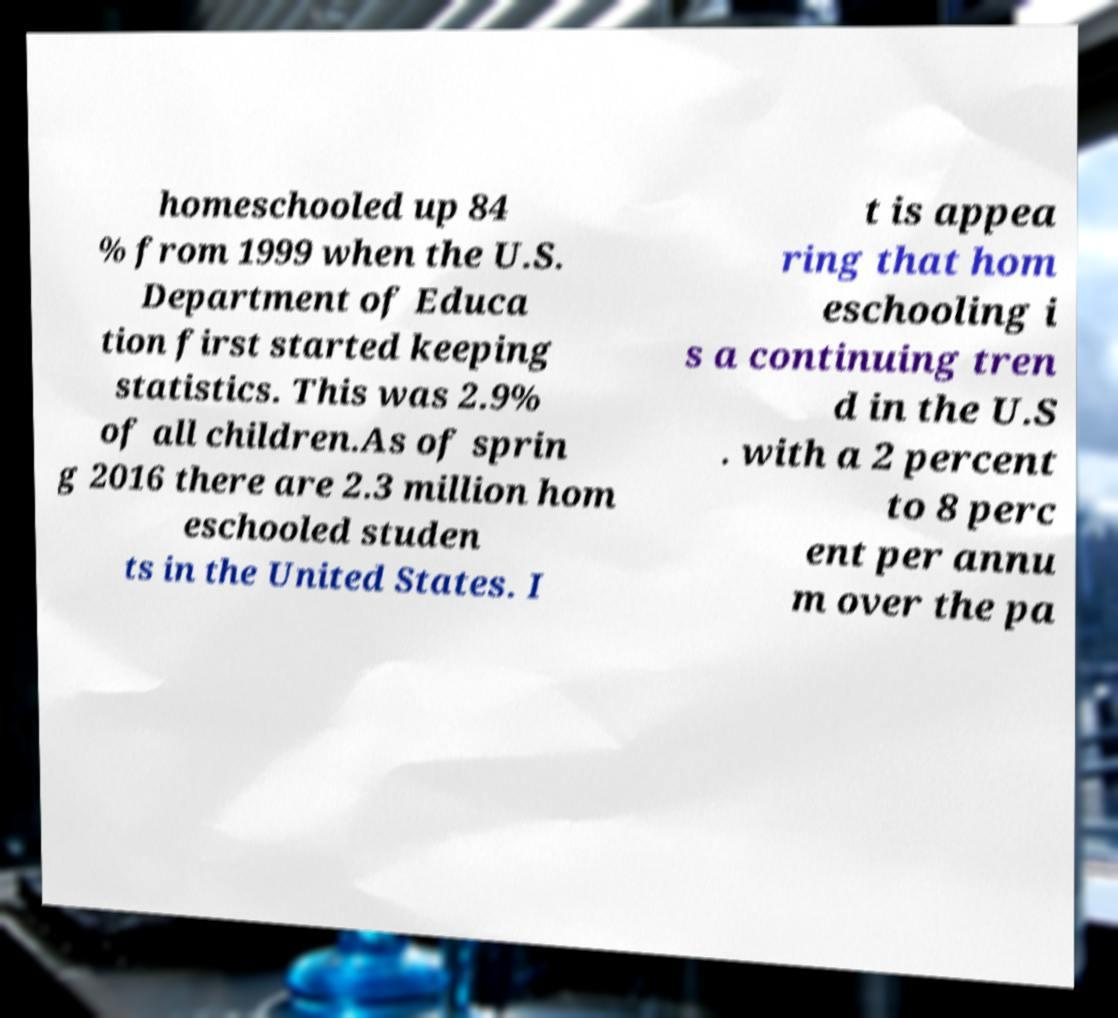Could you assist in decoding the text presented in this image and type it out clearly? homeschooled up 84 % from 1999 when the U.S. Department of Educa tion first started keeping statistics. This was 2.9% of all children.As of sprin g 2016 there are 2.3 million hom eschooled studen ts in the United States. I t is appea ring that hom eschooling i s a continuing tren d in the U.S . with a 2 percent to 8 perc ent per annu m over the pa 